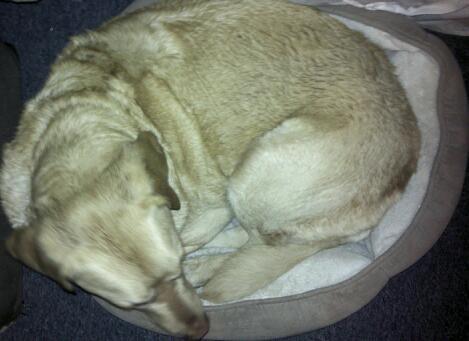How many animals are in the picture?
Give a very brief answer. 1. How many birds are pictured?
Give a very brief answer. 0. 